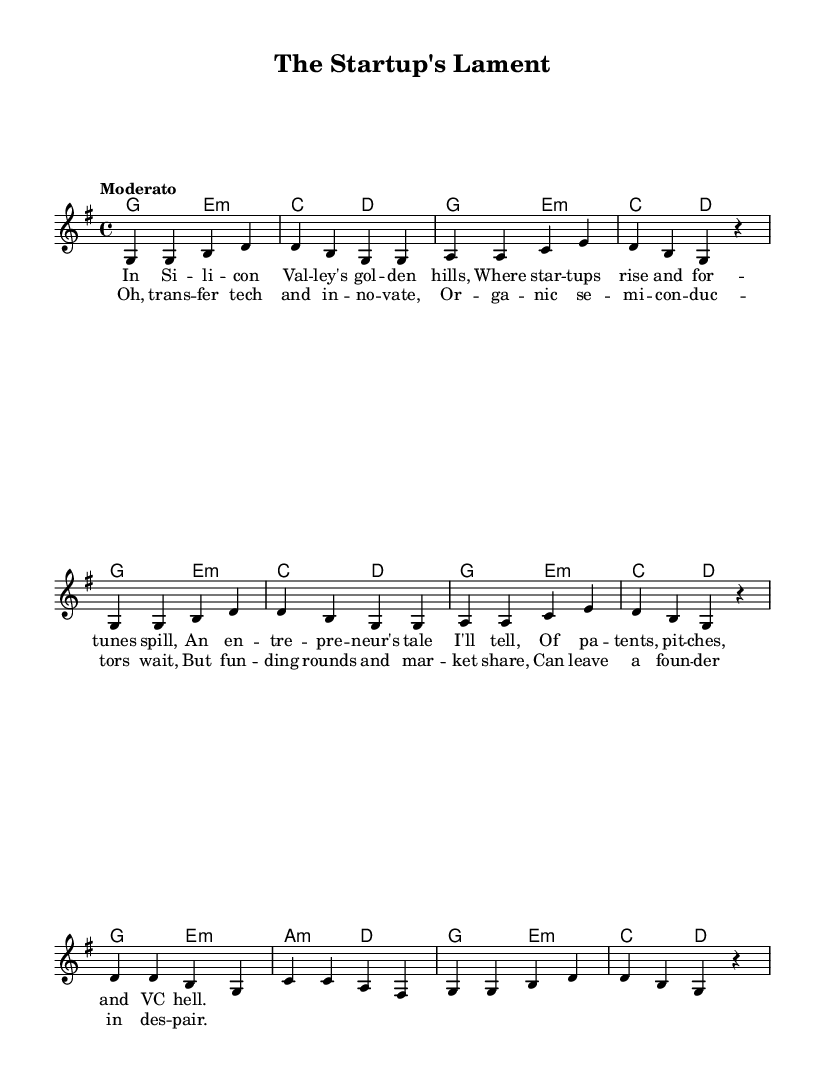What is the key signature of this music? The key signature is G major, which consists of one sharp (F#).
Answer: G major What is the time signature of this music? The time signature is 4/4, indicating there are four beats per measure.
Answer: 4/4 What is the tempo marking for this piece? The tempo marking is "Moderato," which suggests a moderate pace for the music.
Answer: Moderato How many verses are included in the lyrics? There are two verses present in the lyrics section of the sheet music.
Answer: Two How many measures are there in the melody? The melody consists of eight measures, which can be counted from the music notation.
Answer: Eight What type of music is primarily represented by the lyrics? The lyrics are adapted to folk music, showcasing themes common in traditional folk tunes.
Answer: Folk 